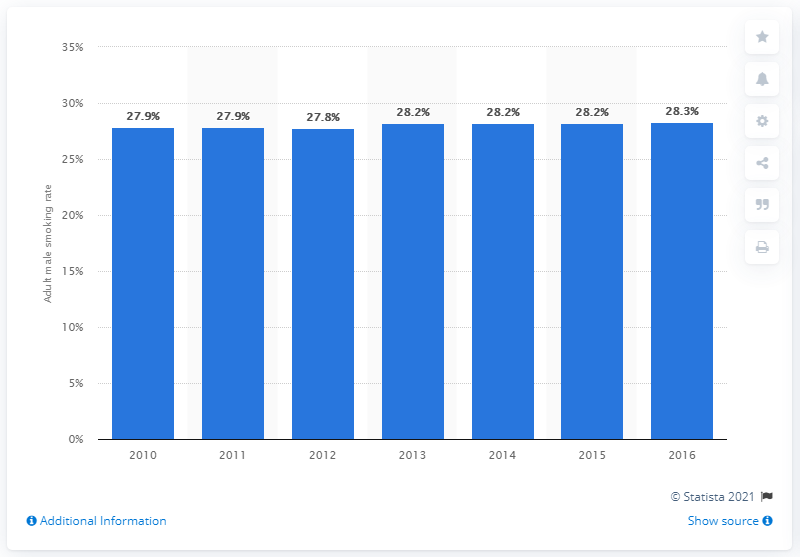Specify some key components in this picture. In 2016, it was reported that 28.3% of males in Singapore smoked. Since 2010, the smoking rate among adult males in Singapore has increased. 